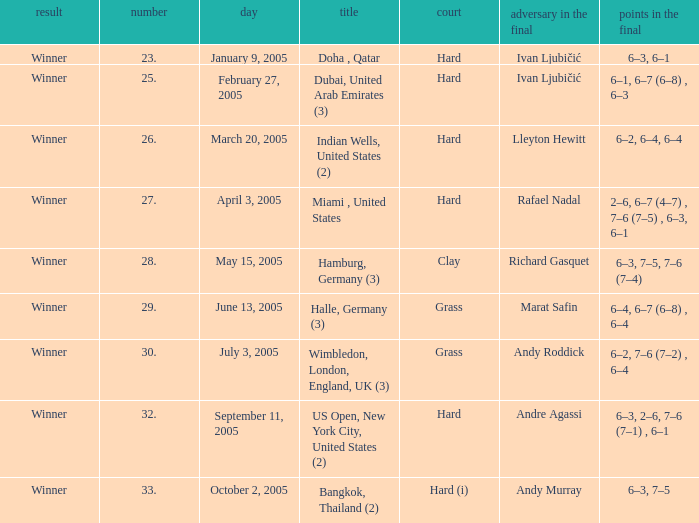Marat Safin is the opponent in the final in what championship? Halle, Germany (3). 